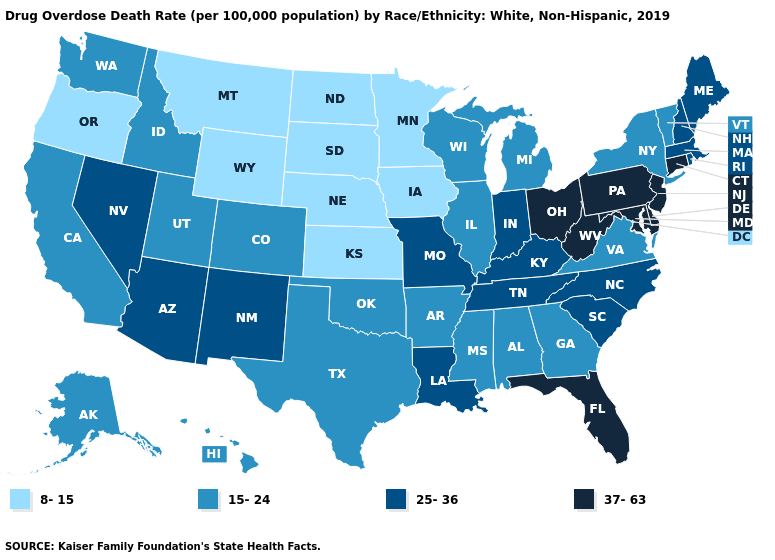Among the states that border New York , which have the highest value?
Keep it brief. Connecticut, New Jersey, Pennsylvania. Among the states that border Georgia , which have the highest value?
Quick response, please. Florida. Is the legend a continuous bar?
Be succinct. No. Name the states that have a value in the range 25-36?
Be succinct. Arizona, Indiana, Kentucky, Louisiana, Maine, Massachusetts, Missouri, Nevada, New Hampshire, New Mexico, North Carolina, Rhode Island, South Carolina, Tennessee. Name the states that have a value in the range 15-24?
Short answer required. Alabama, Alaska, Arkansas, California, Colorado, Georgia, Hawaii, Idaho, Illinois, Michigan, Mississippi, New York, Oklahoma, Texas, Utah, Vermont, Virginia, Washington, Wisconsin. How many symbols are there in the legend?
Write a very short answer. 4. How many symbols are there in the legend?
Write a very short answer. 4. Among the states that border Nebraska , does Kansas have the lowest value?
Keep it brief. Yes. Does the map have missing data?
Write a very short answer. No. How many symbols are there in the legend?
Give a very brief answer. 4. Among the states that border Kentucky , does Ohio have the highest value?
Keep it brief. Yes. Does Kentucky have the highest value in the South?
Write a very short answer. No. Does New Jersey have the highest value in the USA?
Answer briefly. Yes. Does Wisconsin have a lower value than Maine?
Give a very brief answer. Yes. Name the states that have a value in the range 8-15?
Give a very brief answer. Iowa, Kansas, Minnesota, Montana, Nebraska, North Dakota, Oregon, South Dakota, Wyoming. 